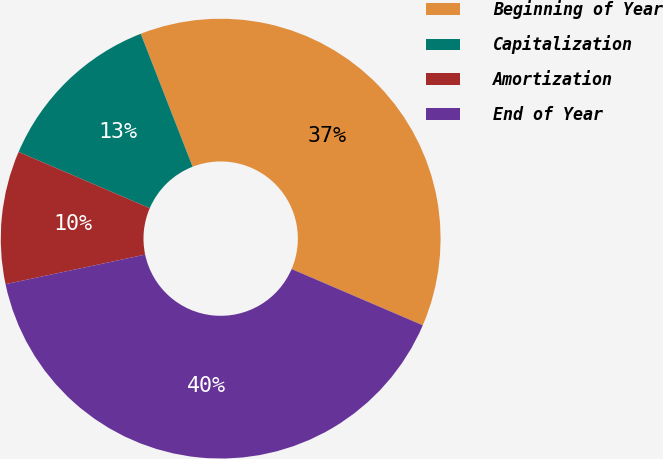<chart> <loc_0><loc_0><loc_500><loc_500><pie_chart><fcel>Beginning of Year<fcel>Capitalization<fcel>Amortization<fcel>End of Year<nl><fcel>37.37%<fcel>12.63%<fcel>9.77%<fcel>40.23%<nl></chart> 